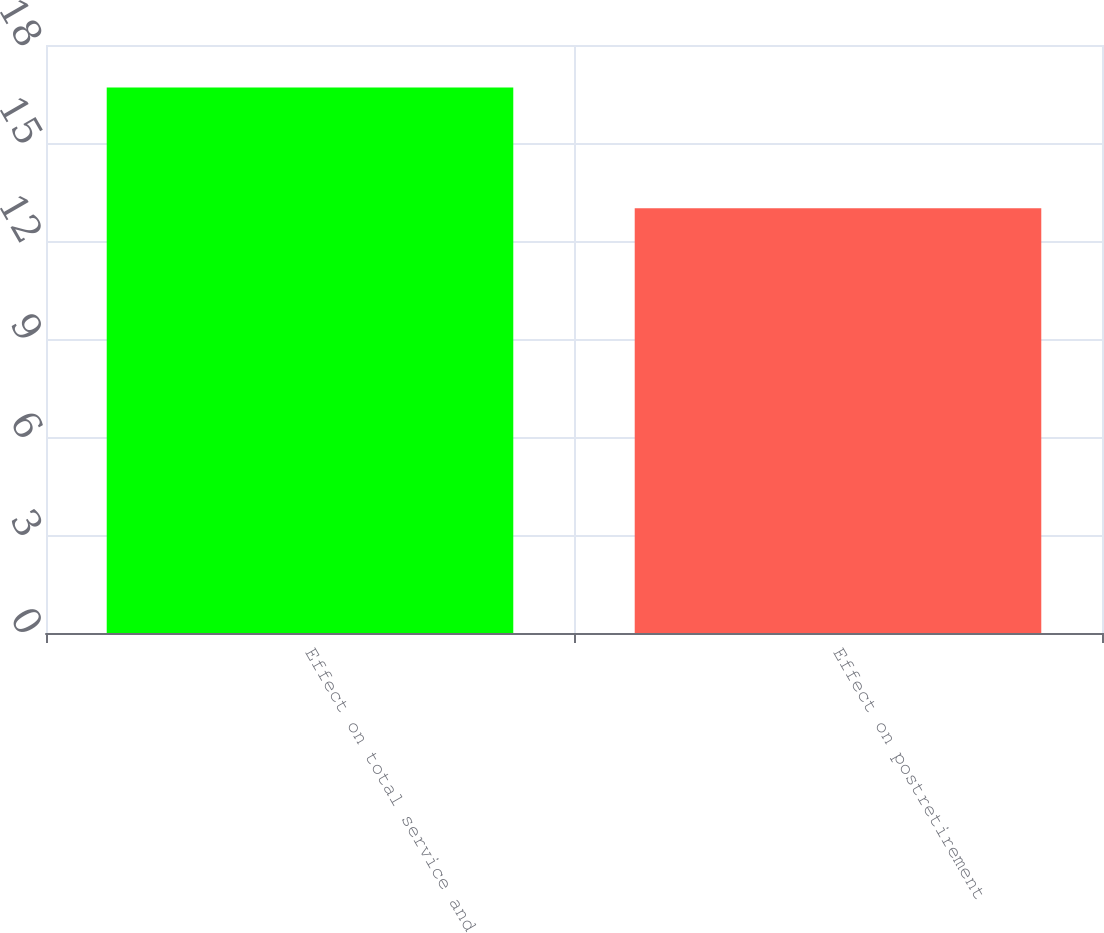<chart> <loc_0><loc_0><loc_500><loc_500><bar_chart><fcel>Effect on total service and<fcel>Effect on postretirement<nl><fcel>16.7<fcel>13<nl></chart> 